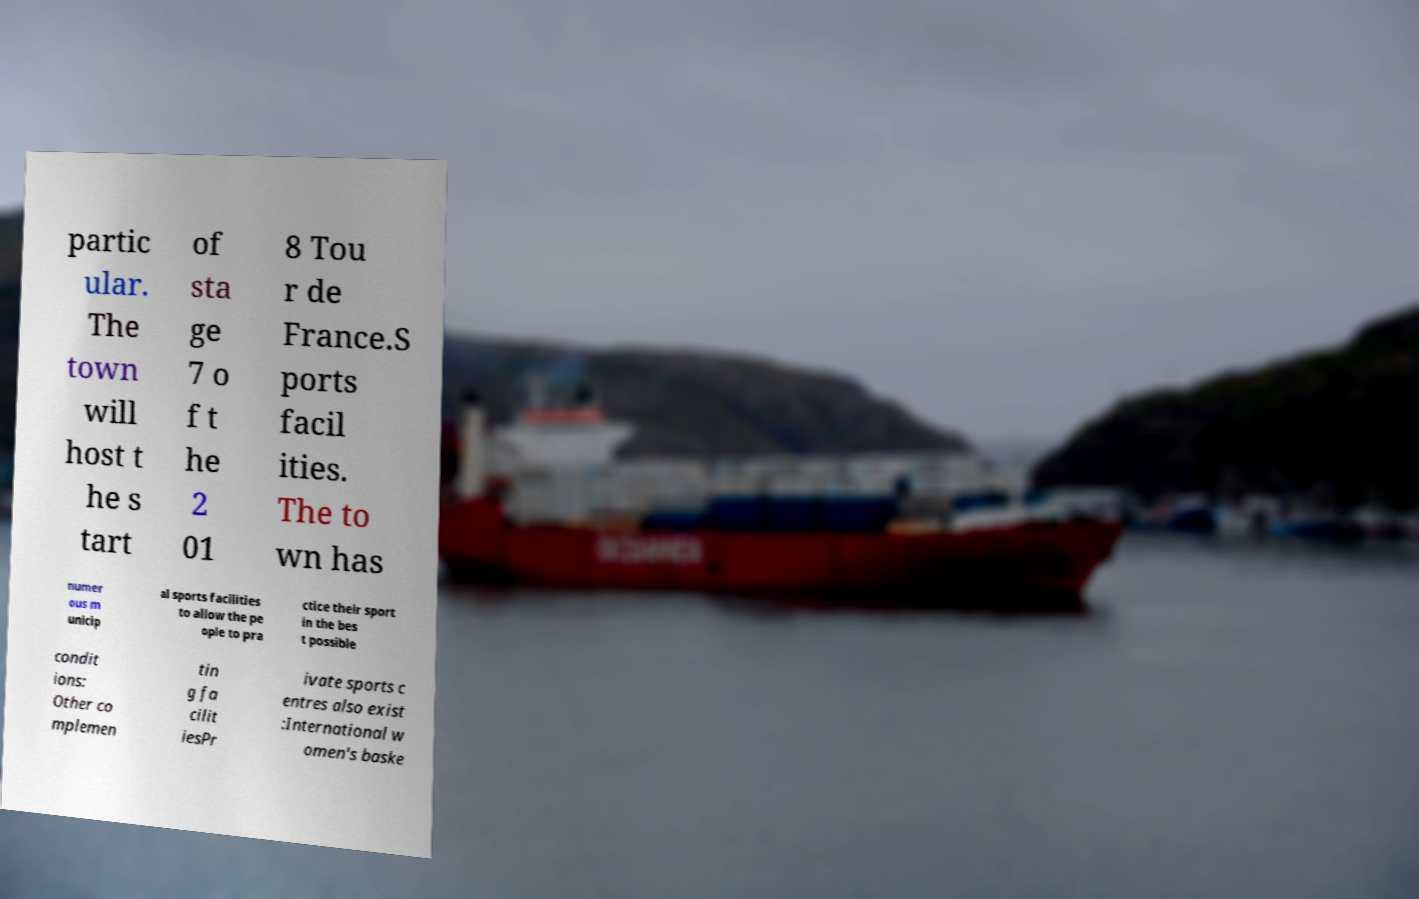I need the written content from this picture converted into text. Can you do that? partic ular. The town will host t he s tart of sta ge 7 o f t he 2 01 8 Tou r de France.S ports facil ities. The to wn has numer ous m unicip al sports facilities to allow the pe ople to pra ctice their sport in the bes t possible condit ions: Other co mplemen tin g fa cilit iesPr ivate sports c entres also exist :International w omen's baske 